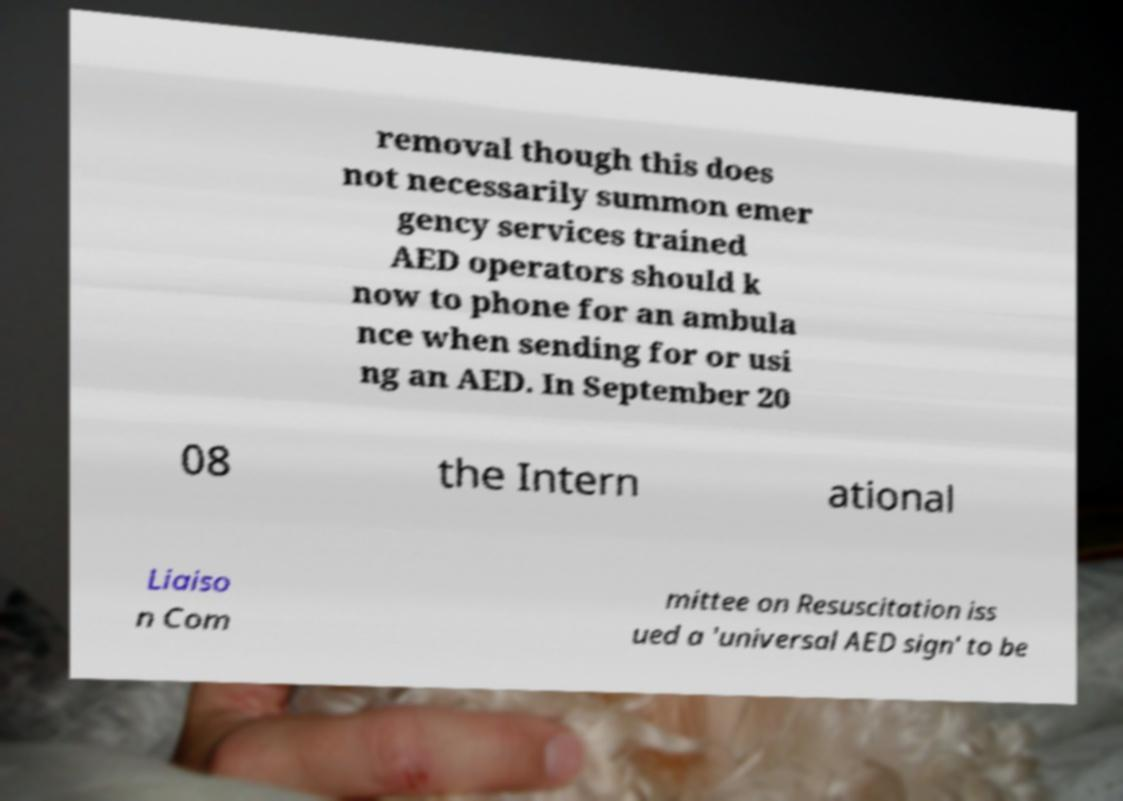I need the written content from this picture converted into text. Can you do that? removal though this does not necessarily summon emer gency services trained AED operators should k now to phone for an ambula nce when sending for or usi ng an AED. In September 20 08 the Intern ational Liaiso n Com mittee on Resuscitation iss ued a 'universal AED sign' to be 